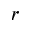<formula> <loc_0><loc_0><loc_500><loc_500>r</formula> 